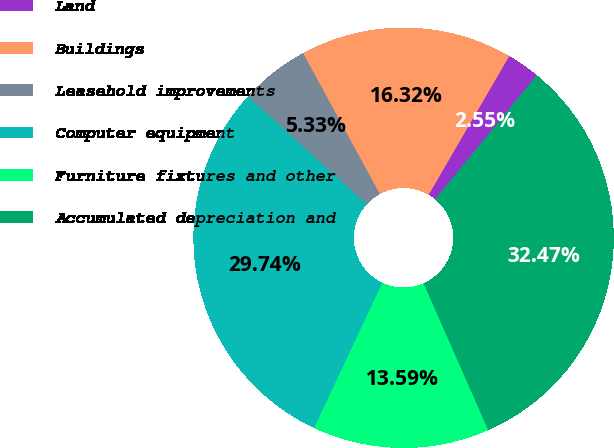<chart> <loc_0><loc_0><loc_500><loc_500><pie_chart><fcel>Land<fcel>Buildings<fcel>Leasehold improvements<fcel>Computer equipment<fcel>Furniture fixtures and other<fcel>Accumulated depreciation and<nl><fcel>2.55%<fcel>16.32%<fcel>5.33%<fcel>29.74%<fcel>13.59%<fcel>32.47%<nl></chart> 